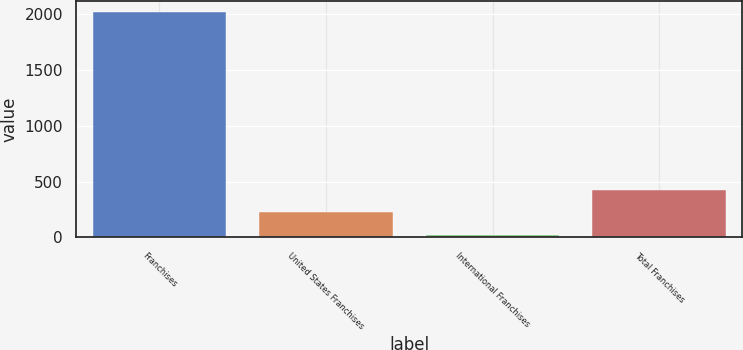Convert chart. <chart><loc_0><loc_0><loc_500><loc_500><bar_chart><fcel>Franchises<fcel>United States Franchises<fcel>International Franchises<fcel>Total Franchises<nl><fcel>2013<fcel>224.7<fcel>26<fcel>423.4<nl></chart> 